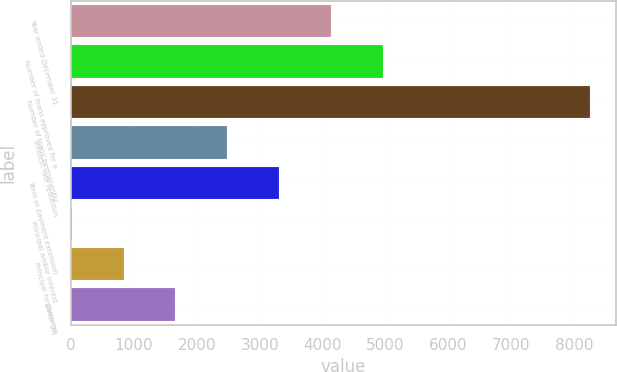Convert chart to OTSL. <chart><loc_0><loc_0><loc_500><loc_500><bar_chart><fcel>Year ended December 31<fcel>Number of loans approved for a<fcel>Number of loans permanently<fcel>Interest rate reduction<fcel>Term or payment extension<fcel>Principal and/or interest<fcel>Principal forgiveness<fcel>Other (b)<nl><fcel>4132<fcel>4956<fcel>8252<fcel>2484<fcel>3308<fcel>12<fcel>836<fcel>1660<nl></chart> 